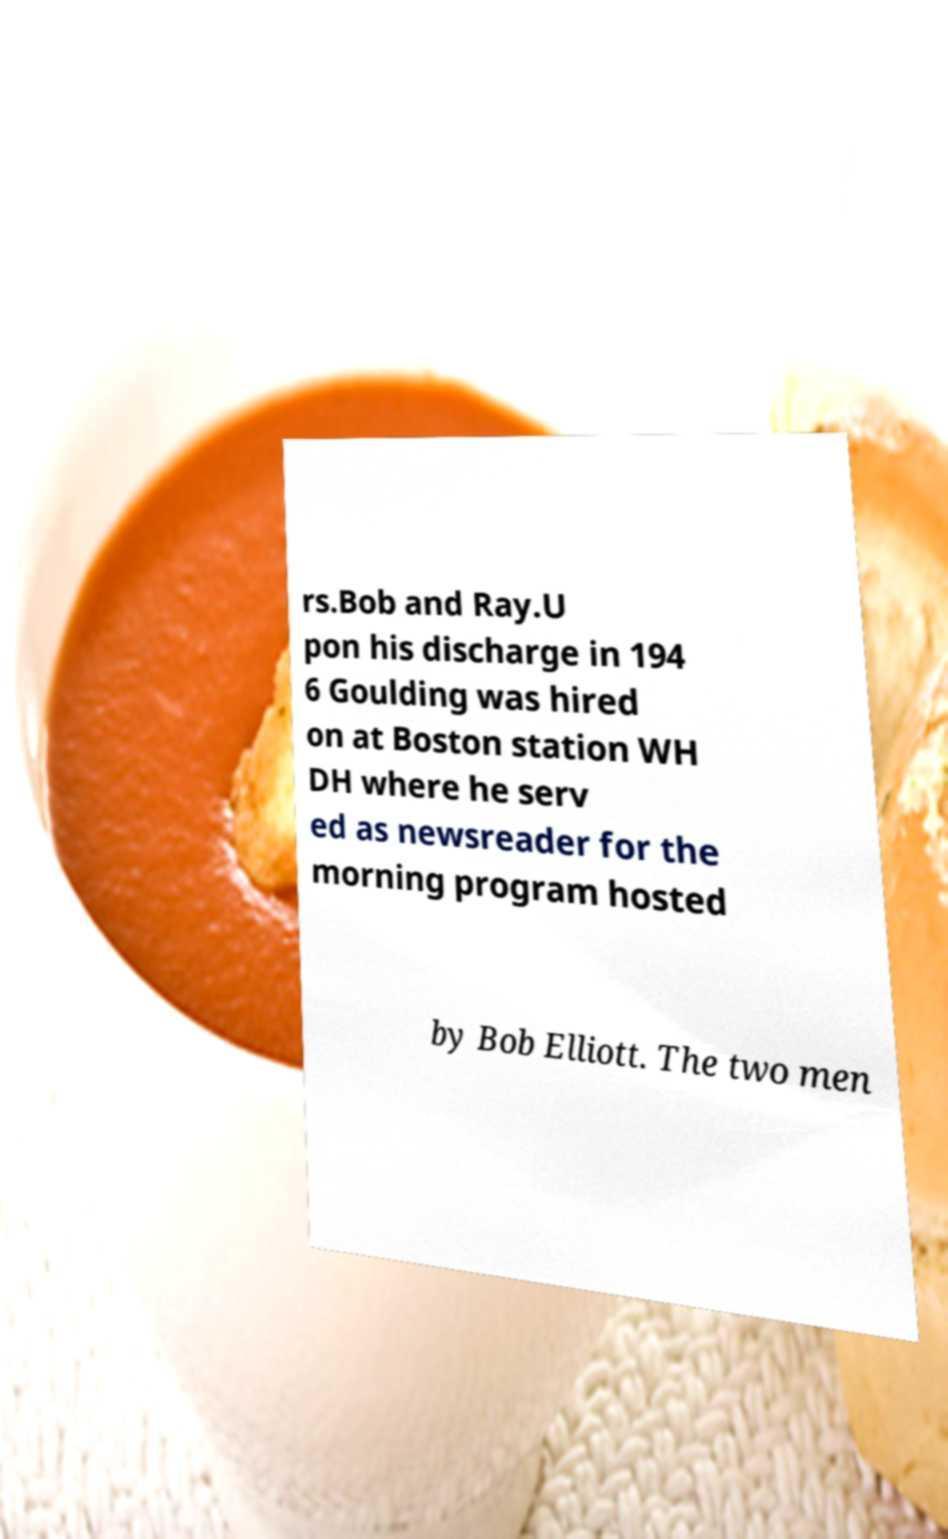Please identify and transcribe the text found in this image. rs.Bob and Ray.U pon his discharge in 194 6 Goulding was hired on at Boston station WH DH where he serv ed as newsreader for the morning program hosted by Bob Elliott. The two men 